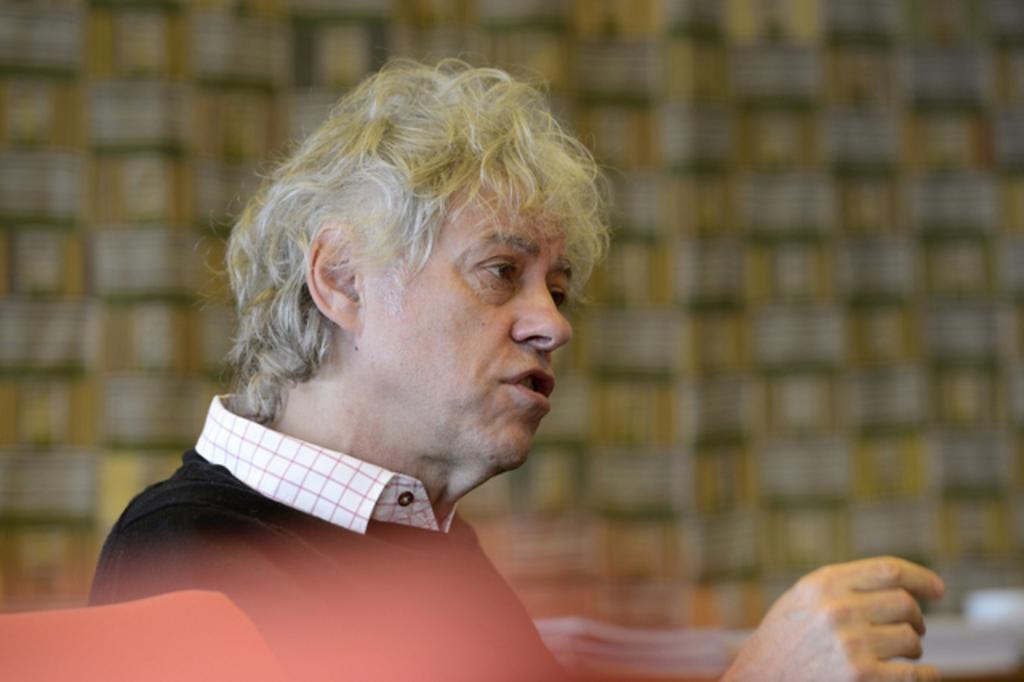How would you summarize this image in a sentence or two? In this image we can see a man sitting. 